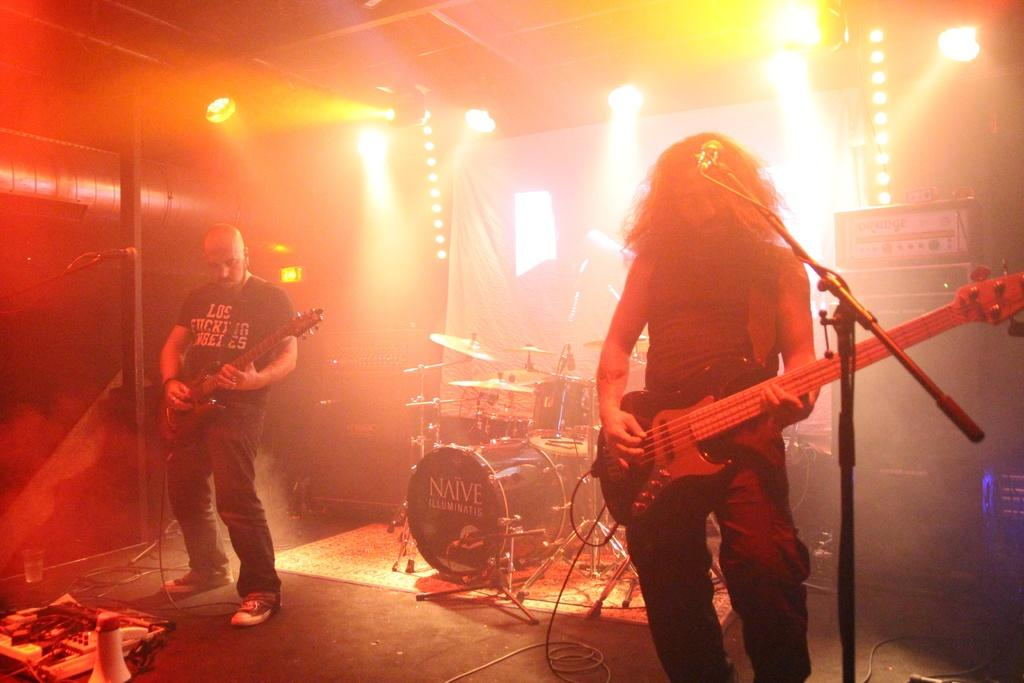How many people are in the image? There are two men in the image. What are the men holding in the image? The men are holding guitars. Can you describe the background of the image? There is a drum set in the background of the image. What type of goat can be seen playing the drums in the image? There is no goat present in the image, and no one is playing the drums. 